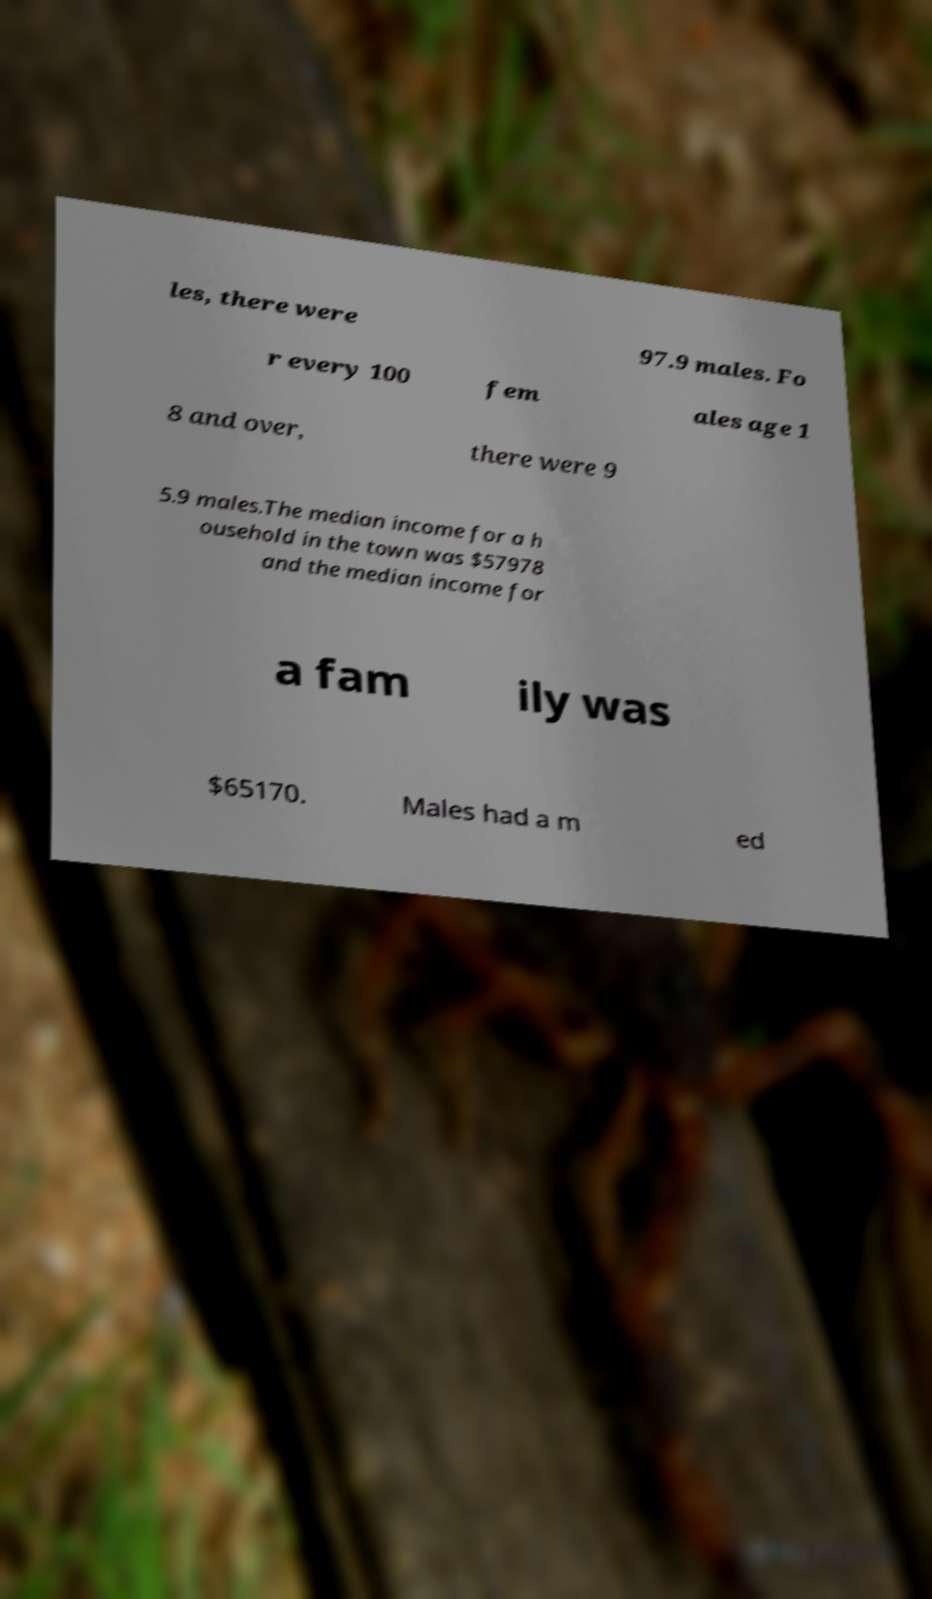Could you extract and type out the text from this image? les, there were 97.9 males. Fo r every 100 fem ales age 1 8 and over, there were 9 5.9 males.The median income for a h ousehold in the town was $57978 and the median income for a fam ily was $65170. Males had a m ed 